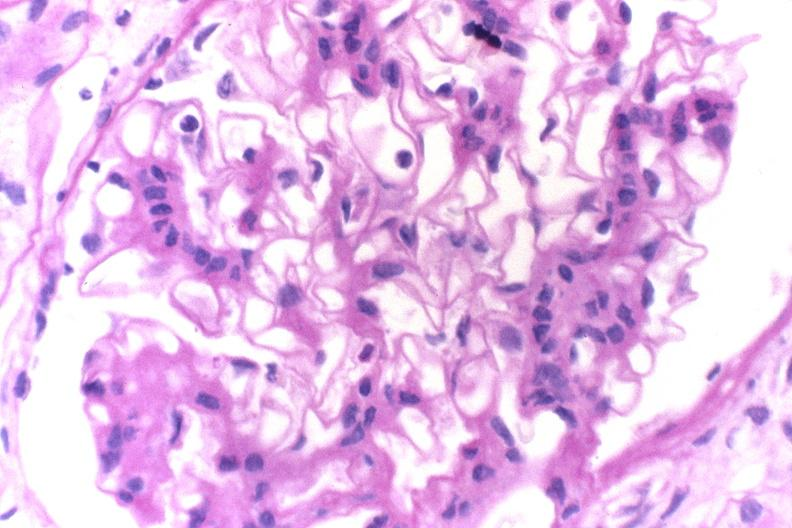does pus in test tube show glomerulonephritis, sle ii?
Answer the question using a single word or phrase. No 